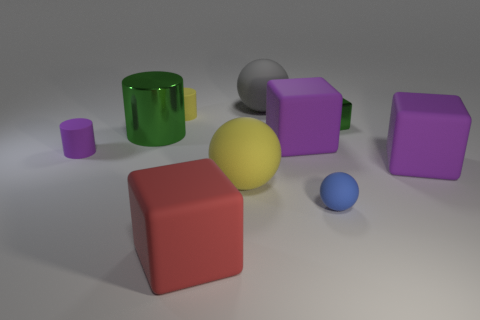Subtract all balls. How many objects are left? 7 Subtract all brown cubes. Subtract all small yellow rubber cylinders. How many objects are left? 9 Add 5 big rubber spheres. How many big rubber spheres are left? 7 Add 2 large red rubber objects. How many large red rubber objects exist? 3 Subtract 0 brown cubes. How many objects are left? 10 